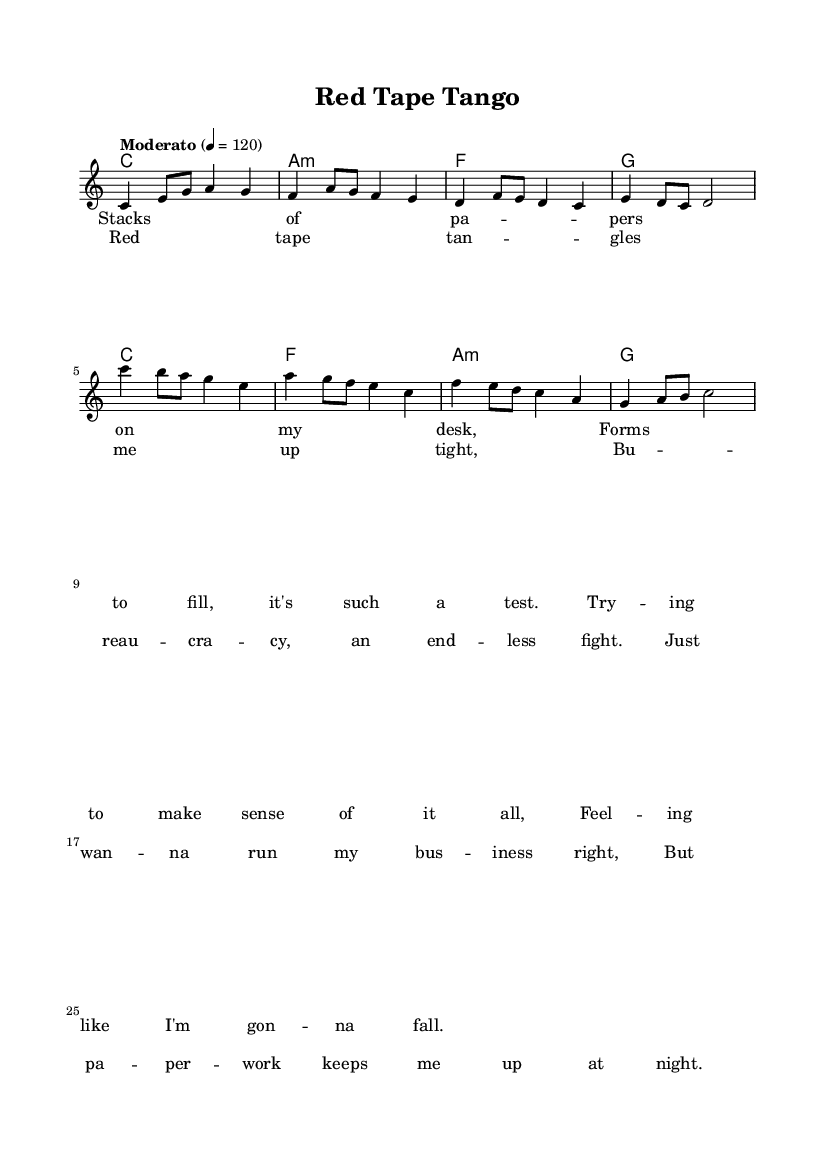What is the key signature of this music? The key signature is C major, which has no sharps or flats indicated at the beginning of the staff.
Answer: C major What is the time signature of this music? The time signature is shown as a fraction at the beginning of the staff, and it indicates four beats in a measure.
Answer: 4/4 What is the tempo marking of this music? The tempo marking is indicated above the staff, specifying a moderate pace of 120 beats per minute.
Answer: Moderato How many measures are in the verse section? By counting the music notation, there are a total of four measures in the verse section of the song, as each line contains four counts.
Answer: 4 What is the first chord used in the verse? The first chord is found at the beginning of the verse and indicated with the letter above the staff; it specifies the chord played.
Answer: C What word describes the main theme of the lyrics? The lyrics focus on the challenges and frustrations one faces in dealing with bureaucratic processes, reflected in the usage of bureaucratic terminology in the text.
Answer: Bureaucracy Which lyrics section follows the chorus in this song? The structure of the song dictates that after the chorus comes the verse; we can see by the layout of the lyrics where it's clearly marked.
Answer: Verse 